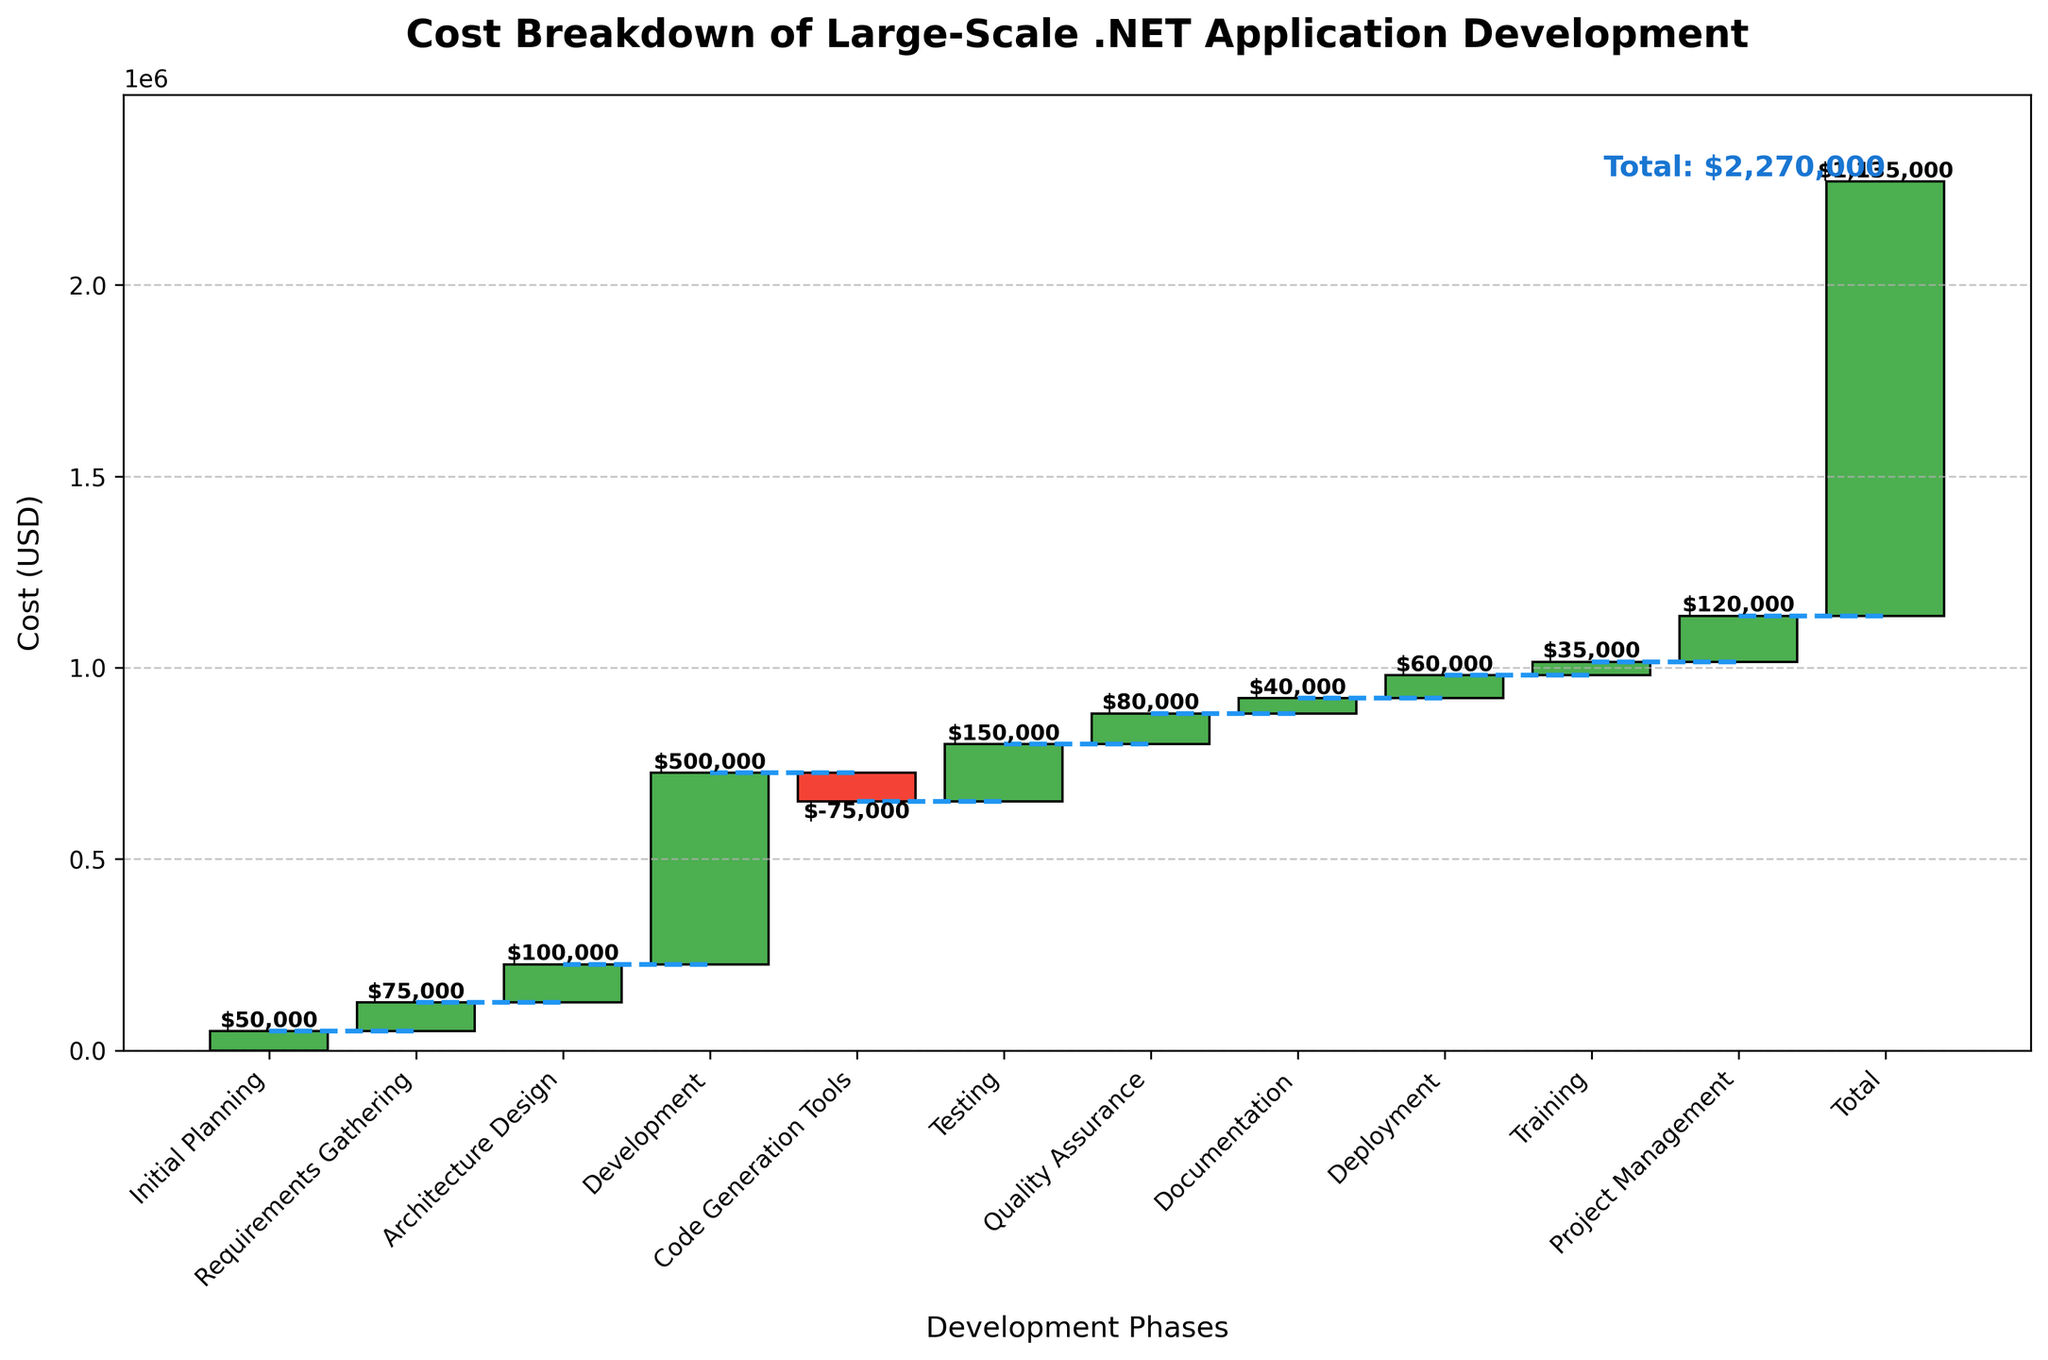What is the title of the chart? The title is displayed at the top of the chart. It reads "Cost Breakdown of Large-Scale .NET Application Development."
Answer: Cost Breakdown of Large-Scale .NET Application Development What is the cost value for the "Development" phase? You can find the cost value for each phase by looking at the respective bar. For the "Development" phase, the bar indicates a value of $500,000.
Answer: $500,000 How does the cost of "Testing" compare to the cost of "Quality Assurance"? To compare the costs, look at the heights of the bars or the labels. Testing costs $150,000, while Quality Assurance costs $80,000. Testing is more expensive.
Answer: Testing is more expensive What is the total cost by the end of the deployment phase? The cumulative cost after each phase can be seen in the blocks connected by dotted lines. By the end of the Deployment phase, the total cost is $1,045,000.
Answer: $1,045,000 How many phases contribute positively to the cumulative cost? Each phase can either add (positive value) or subtract (negative value) from the cumulative cost. All phases have positive contributions except for "Code Generation Tools".
Answer: 10 phases What is the net effect of the "Code Generation Tools" on the total cost? The "Code Generation Tools" phase has a negative cost value. The effect is seen as a reduction of $75,000 from the cumulative cost.
Answer: -$75,000 What is the highest individual cost phase, and what is its value? The highest individual cost phase is identified by finding the tallest bar or the largest value labeled. "Development" is the highest, costing $500,000.
Answer: Development, $500,000 Which phase has the lowest positive contribution to the total cost? To find the lowest positive contribution, look for the shortest bar with a positive value. The "Training" phase has the lowest contribution with $35,000.
Answer: Training, $35,000 What is the difference in cost between "Initial Planning" and "Project Management"? Subtract the cost of "Initial Planning" ($50,000) from "Project Management" ($120,000). The difference is $70,000.
Answer: $70,000 What is the cumulative cost after the "Documentation" phase? Follow the cumulative cost lines or add the costs up to the "Documentation" phase. The total up to "Documentation" is $935,000.
Answer: $935,000 